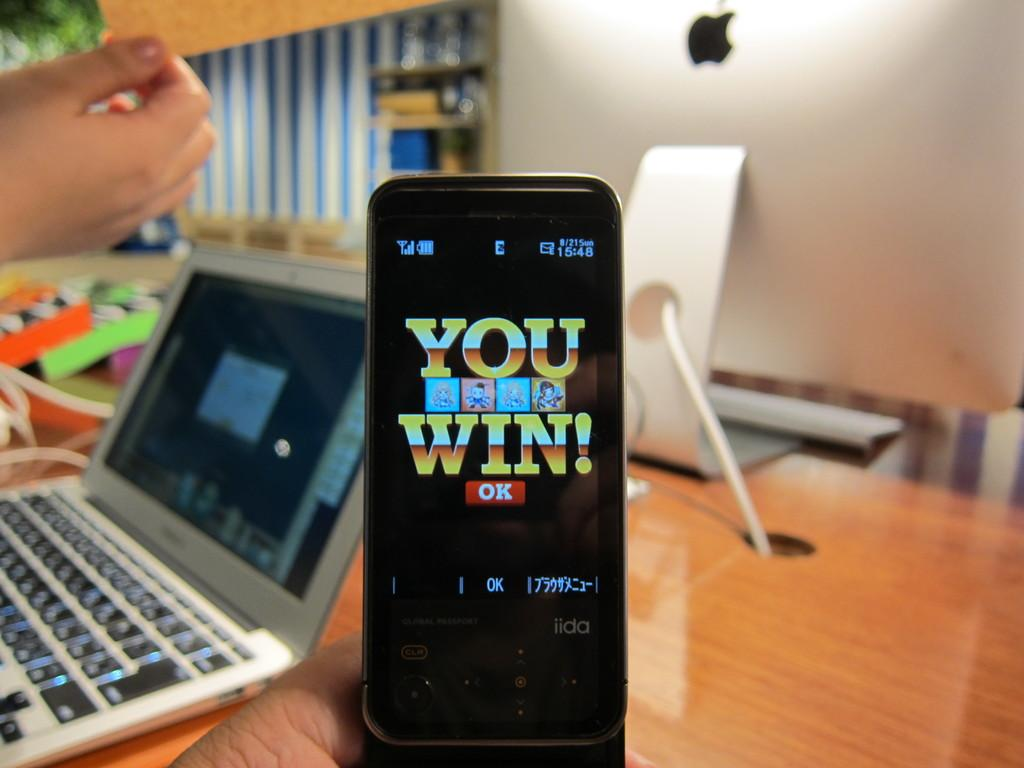<image>
Give a short and clear explanation of the subsequent image. A small cell phone is being held up that says You Win. 